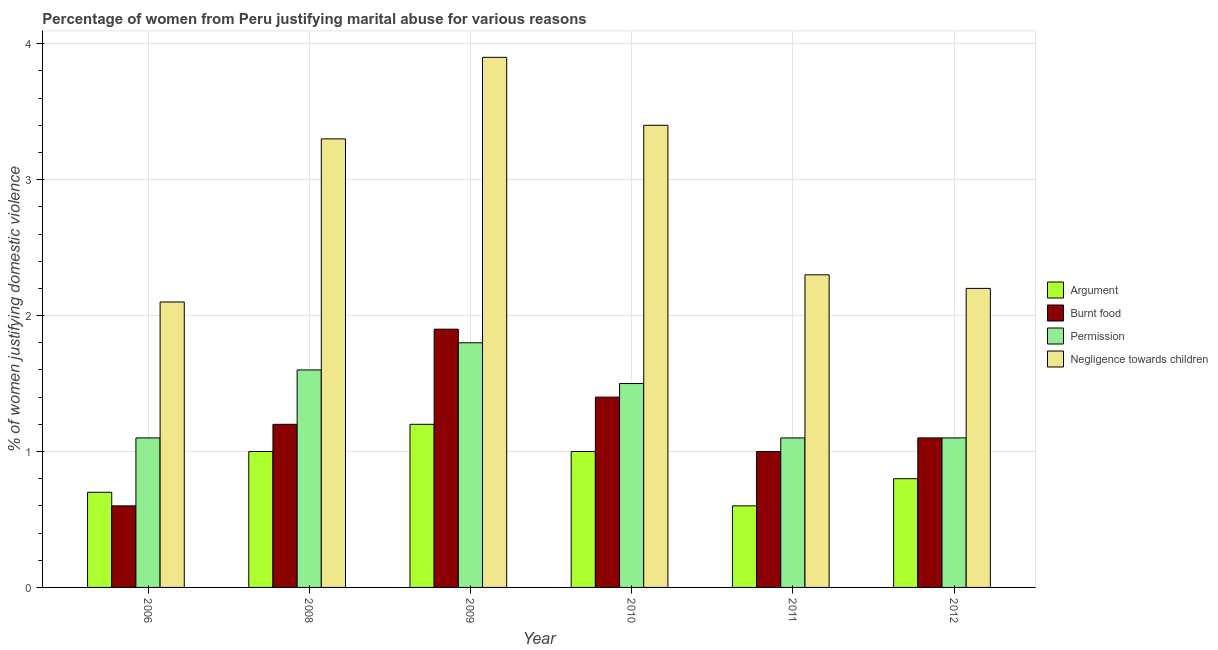How many groups of bars are there?
Your answer should be compact. 6. Are the number of bars on each tick of the X-axis equal?
Your response must be concise. Yes. How many bars are there on the 1st tick from the left?
Give a very brief answer. 4. What is the label of the 4th group of bars from the left?
Make the answer very short. 2010. Across all years, what is the maximum percentage of women justifying abuse in the case of an argument?
Give a very brief answer. 1.2. Across all years, what is the minimum percentage of women justifying abuse for burning food?
Ensure brevity in your answer.  0.6. What is the difference between the percentage of women justifying abuse for burning food in 2006 and that in 2009?
Provide a short and direct response. -1.3. What is the difference between the percentage of women justifying abuse for going without permission in 2008 and the percentage of women justifying abuse for burning food in 2006?
Ensure brevity in your answer.  0.5. What is the average percentage of women justifying abuse for showing negligence towards children per year?
Provide a short and direct response. 2.87. In how many years, is the percentage of women justifying abuse for going without permission greater than 1.8 %?
Offer a very short reply. 0. What is the ratio of the percentage of women justifying abuse for going without permission in 2009 to that in 2010?
Keep it short and to the point. 1.2. Is the percentage of women justifying abuse in the case of an argument in 2006 less than that in 2009?
Your answer should be compact. Yes. Is the difference between the percentage of women justifying abuse for going without permission in 2006 and 2010 greater than the difference between the percentage of women justifying abuse for showing negligence towards children in 2006 and 2010?
Give a very brief answer. No. What is the difference between the highest and the second highest percentage of women justifying abuse in the case of an argument?
Provide a succinct answer. 0.2. What is the difference between the highest and the lowest percentage of women justifying abuse for burning food?
Provide a succinct answer. 1.3. In how many years, is the percentage of women justifying abuse in the case of an argument greater than the average percentage of women justifying abuse in the case of an argument taken over all years?
Ensure brevity in your answer.  3. What does the 3rd bar from the left in 2012 represents?
Offer a terse response. Permission. What does the 2nd bar from the right in 2010 represents?
Provide a succinct answer. Permission. Is it the case that in every year, the sum of the percentage of women justifying abuse in the case of an argument and percentage of women justifying abuse for burning food is greater than the percentage of women justifying abuse for going without permission?
Provide a short and direct response. Yes. How many years are there in the graph?
Make the answer very short. 6. What is the difference between two consecutive major ticks on the Y-axis?
Offer a very short reply. 1. Does the graph contain any zero values?
Your answer should be compact. No. How many legend labels are there?
Offer a terse response. 4. How are the legend labels stacked?
Make the answer very short. Vertical. What is the title of the graph?
Keep it short and to the point. Percentage of women from Peru justifying marital abuse for various reasons. What is the label or title of the Y-axis?
Offer a terse response. % of women justifying domestic violence. What is the % of women justifying domestic violence of Argument in 2006?
Ensure brevity in your answer.  0.7. What is the % of women justifying domestic violence in Argument in 2008?
Provide a succinct answer. 1. What is the % of women justifying domestic violence of Burnt food in 2008?
Offer a very short reply. 1.2. What is the % of women justifying domestic violence in Negligence towards children in 2008?
Keep it short and to the point. 3.3. What is the % of women justifying domestic violence in Burnt food in 2009?
Give a very brief answer. 1.9. What is the % of women justifying domestic violence in Burnt food in 2010?
Ensure brevity in your answer.  1.4. What is the % of women justifying domestic violence of Permission in 2010?
Provide a succinct answer. 1.5. What is the % of women justifying domestic violence of Burnt food in 2011?
Give a very brief answer. 1. What is the % of women justifying domestic violence in Permission in 2011?
Offer a terse response. 1.1. What is the % of women justifying domestic violence of Argument in 2012?
Offer a very short reply. 0.8. What is the % of women justifying domestic violence in Burnt food in 2012?
Provide a short and direct response. 1.1. Across all years, what is the maximum % of women justifying domestic violence in Permission?
Make the answer very short. 1.8. Across all years, what is the minimum % of women justifying domestic violence of Permission?
Your response must be concise. 1.1. What is the total % of women justifying domestic violence of Argument in the graph?
Provide a succinct answer. 5.3. What is the total % of women justifying domestic violence of Permission in the graph?
Provide a succinct answer. 8.2. What is the total % of women justifying domestic violence of Negligence towards children in the graph?
Provide a succinct answer. 17.2. What is the difference between the % of women justifying domestic violence of Argument in 2006 and that in 2009?
Offer a very short reply. -0.5. What is the difference between the % of women justifying domestic violence in Burnt food in 2006 and that in 2009?
Keep it short and to the point. -1.3. What is the difference between the % of women justifying domestic violence in Argument in 2006 and that in 2010?
Provide a succinct answer. -0.3. What is the difference between the % of women justifying domestic violence of Burnt food in 2006 and that in 2010?
Give a very brief answer. -0.8. What is the difference between the % of women justifying domestic violence in Negligence towards children in 2006 and that in 2010?
Your response must be concise. -1.3. What is the difference between the % of women justifying domestic violence of Burnt food in 2006 and that in 2011?
Give a very brief answer. -0.4. What is the difference between the % of women justifying domestic violence of Permission in 2006 and that in 2012?
Your answer should be compact. 0. What is the difference between the % of women justifying domestic violence of Negligence towards children in 2006 and that in 2012?
Offer a very short reply. -0.1. What is the difference between the % of women justifying domestic violence in Burnt food in 2008 and that in 2009?
Provide a short and direct response. -0.7. What is the difference between the % of women justifying domestic violence of Negligence towards children in 2008 and that in 2009?
Ensure brevity in your answer.  -0.6. What is the difference between the % of women justifying domestic violence in Burnt food in 2008 and that in 2010?
Your response must be concise. -0.2. What is the difference between the % of women justifying domestic violence of Permission in 2008 and that in 2010?
Your response must be concise. 0.1. What is the difference between the % of women justifying domestic violence of Burnt food in 2008 and that in 2011?
Keep it short and to the point. 0.2. What is the difference between the % of women justifying domestic violence in Negligence towards children in 2008 and that in 2011?
Your response must be concise. 1. What is the difference between the % of women justifying domestic violence in Burnt food in 2008 and that in 2012?
Your response must be concise. 0.1. What is the difference between the % of women justifying domestic violence in Permission in 2008 and that in 2012?
Your response must be concise. 0.5. What is the difference between the % of women justifying domestic violence in Negligence towards children in 2008 and that in 2012?
Offer a very short reply. 1.1. What is the difference between the % of women justifying domestic violence of Negligence towards children in 2009 and that in 2010?
Keep it short and to the point. 0.5. What is the difference between the % of women justifying domestic violence in Burnt food in 2009 and that in 2011?
Offer a terse response. 0.9. What is the difference between the % of women justifying domestic violence in Negligence towards children in 2009 and that in 2011?
Your answer should be very brief. 1.6. What is the difference between the % of women justifying domestic violence of Argument in 2009 and that in 2012?
Make the answer very short. 0.4. What is the difference between the % of women justifying domestic violence in Burnt food in 2009 and that in 2012?
Ensure brevity in your answer.  0.8. What is the difference between the % of women justifying domestic violence of Negligence towards children in 2010 and that in 2012?
Make the answer very short. 1.2. What is the difference between the % of women justifying domestic violence of Argument in 2011 and that in 2012?
Your answer should be very brief. -0.2. What is the difference between the % of women justifying domestic violence in Burnt food in 2011 and that in 2012?
Make the answer very short. -0.1. What is the difference between the % of women justifying domestic violence in Permission in 2011 and that in 2012?
Give a very brief answer. 0. What is the difference between the % of women justifying domestic violence in Burnt food in 2006 and the % of women justifying domestic violence in Negligence towards children in 2008?
Make the answer very short. -2.7. What is the difference between the % of women justifying domestic violence in Argument in 2006 and the % of women justifying domestic violence in Permission in 2009?
Provide a short and direct response. -1.1. What is the difference between the % of women justifying domestic violence of Argument in 2006 and the % of women justifying domestic violence of Negligence towards children in 2009?
Give a very brief answer. -3.2. What is the difference between the % of women justifying domestic violence in Burnt food in 2006 and the % of women justifying domestic violence in Negligence towards children in 2009?
Provide a short and direct response. -3.3. What is the difference between the % of women justifying domestic violence of Argument in 2006 and the % of women justifying domestic violence of Burnt food in 2010?
Give a very brief answer. -0.7. What is the difference between the % of women justifying domestic violence in Argument in 2006 and the % of women justifying domestic violence in Permission in 2010?
Offer a very short reply. -0.8. What is the difference between the % of women justifying domestic violence in Argument in 2006 and the % of women justifying domestic violence in Negligence towards children in 2010?
Offer a very short reply. -2.7. What is the difference between the % of women justifying domestic violence in Permission in 2006 and the % of women justifying domestic violence in Negligence towards children in 2010?
Make the answer very short. -2.3. What is the difference between the % of women justifying domestic violence of Argument in 2006 and the % of women justifying domestic violence of Permission in 2011?
Your answer should be very brief. -0.4. What is the difference between the % of women justifying domestic violence in Burnt food in 2006 and the % of women justifying domestic violence in Permission in 2011?
Keep it short and to the point. -0.5. What is the difference between the % of women justifying domestic violence in Burnt food in 2006 and the % of women justifying domestic violence in Permission in 2012?
Make the answer very short. -0.5. What is the difference between the % of women justifying domestic violence in Burnt food in 2006 and the % of women justifying domestic violence in Negligence towards children in 2012?
Keep it short and to the point. -1.6. What is the difference between the % of women justifying domestic violence in Permission in 2006 and the % of women justifying domestic violence in Negligence towards children in 2012?
Your response must be concise. -1.1. What is the difference between the % of women justifying domestic violence in Burnt food in 2008 and the % of women justifying domestic violence in Permission in 2009?
Keep it short and to the point. -0.6. What is the difference between the % of women justifying domestic violence in Argument in 2008 and the % of women justifying domestic violence in Negligence towards children in 2010?
Provide a succinct answer. -2.4. What is the difference between the % of women justifying domestic violence in Burnt food in 2008 and the % of women justifying domestic violence in Negligence towards children in 2010?
Offer a very short reply. -2.2. What is the difference between the % of women justifying domestic violence of Permission in 2008 and the % of women justifying domestic violence of Negligence towards children in 2010?
Provide a succinct answer. -1.8. What is the difference between the % of women justifying domestic violence in Argument in 2008 and the % of women justifying domestic violence in Negligence towards children in 2011?
Provide a short and direct response. -1.3. What is the difference between the % of women justifying domestic violence of Argument in 2008 and the % of women justifying domestic violence of Burnt food in 2012?
Offer a terse response. -0.1. What is the difference between the % of women justifying domestic violence of Argument in 2008 and the % of women justifying domestic violence of Permission in 2012?
Give a very brief answer. -0.1. What is the difference between the % of women justifying domestic violence in Burnt food in 2008 and the % of women justifying domestic violence in Negligence towards children in 2012?
Your answer should be compact. -1. What is the difference between the % of women justifying domestic violence in Argument in 2009 and the % of women justifying domestic violence in Burnt food in 2010?
Offer a very short reply. -0.2. What is the difference between the % of women justifying domestic violence of Burnt food in 2009 and the % of women justifying domestic violence of Permission in 2010?
Provide a succinct answer. 0.4. What is the difference between the % of women justifying domestic violence of Argument in 2009 and the % of women justifying domestic violence of Permission in 2011?
Make the answer very short. 0.1. What is the difference between the % of women justifying domestic violence of Burnt food in 2009 and the % of women justifying domestic violence of Permission in 2011?
Provide a short and direct response. 0.8. What is the difference between the % of women justifying domestic violence in Argument in 2009 and the % of women justifying domestic violence in Permission in 2012?
Your response must be concise. 0.1. What is the difference between the % of women justifying domestic violence of Burnt food in 2009 and the % of women justifying domestic violence of Negligence towards children in 2012?
Offer a terse response. -0.3. What is the difference between the % of women justifying domestic violence in Argument in 2010 and the % of women justifying domestic violence in Negligence towards children in 2011?
Offer a terse response. -1.3. What is the difference between the % of women justifying domestic violence in Argument in 2010 and the % of women justifying domestic violence in Negligence towards children in 2012?
Your response must be concise. -1.2. What is the difference between the % of women justifying domestic violence in Burnt food in 2010 and the % of women justifying domestic violence in Permission in 2012?
Offer a very short reply. 0.3. What is the difference between the % of women justifying domestic violence of Argument in 2011 and the % of women justifying domestic violence of Burnt food in 2012?
Give a very brief answer. -0.5. What is the difference between the % of women justifying domestic violence of Argument in 2011 and the % of women justifying domestic violence of Permission in 2012?
Give a very brief answer. -0.5. What is the difference between the % of women justifying domestic violence in Argument in 2011 and the % of women justifying domestic violence in Negligence towards children in 2012?
Your response must be concise. -1.6. What is the difference between the % of women justifying domestic violence of Permission in 2011 and the % of women justifying domestic violence of Negligence towards children in 2012?
Make the answer very short. -1.1. What is the average % of women justifying domestic violence in Argument per year?
Provide a succinct answer. 0.88. What is the average % of women justifying domestic violence of Burnt food per year?
Keep it short and to the point. 1.2. What is the average % of women justifying domestic violence of Permission per year?
Provide a succinct answer. 1.37. What is the average % of women justifying domestic violence of Negligence towards children per year?
Offer a very short reply. 2.87. In the year 2006, what is the difference between the % of women justifying domestic violence of Burnt food and % of women justifying domestic violence of Permission?
Your answer should be compact. -0.5. In the year 2006, what is the difference between the % of women justifying domestic violence of Burnt food and % of women justifying domestic violence of Negligence towards children?
Ensure brevity in your answer.  -1.5. In the year 2006, what is the difference between the % of women justifying domestic violence in Permission and % of women justifying domestic violence in Negligence towards children?
Provide a succinct answer. -1. In the year 2008, what is the difference between the % of women justifying domestic violence of Permission and % of women justifying domestic violence of Negligence towards children?
Make the answer very short. -1.7. In the year 2009, what is the difference between the % of women justifying domestic violence of Permission and % of women justifying domestic violence of Negligence towards children?
Your response must be concise. -2.1. In the year 2010, what is the difference between the % of women justifying domestic violence in Argument and % of women justifying domestic violence in Burnt food?
Ensure brevity in your answer.  -0.4. In the year 2010, what is the difference between the % of women justifying domestic violence in Argument and % of women justifying domestic violence in Permission?
Your answer should be very brief. -0.5. In the year 2010, what is the difference between the % of women justifying domestic violence in Burnt food and % of women justifying domestic violence in Negligence towards children?
Ensure brevity in your answer.  -2. In the year 2010, what is the difference between the % of women justifying domestic violence in Permission and % of women justifying domestic violence in Negligence towards children?
Your response must be concise. -1.9. In the year 2011, what is the difference between the % of women justifying domestic violence of Argument and % of women justifying domestic violence of Burnt food?
Your answer should be very brief. -0.4. In the year 2011, what is the difference between the % of women justifying domestic violence of Argument and % of women justifying domestic violence of Negligence towards children?
Provide a succinct answer. -1.7. In the year 2011, what is the difference between the % of women justifying domestic violence of Burnt food and % of women justifying domestic violence of Negligence towards children?
Give a very brief answer. -1.3. In the year 2012, what is the difference between the % of women justifying domestic violence in Argument and % of women justifying domestic violence in Permission?
Give a very brief answer. -0.3. In the year 2012, what is the difference between the % of women justifying domestic violence of Argument and % of women justifying domestic violence of Negligence towards children?
Offer a very short reply. -1.4. In the year 2012, what is the difference between the % of women justifying domestic violence in Burnt food and % of women justifying domestic violence in Negligence towards children?
Offer a terse response. -1.1. What is the ratio of the % of women justifying domestic violence in Burnt food in 2006 to that in 2008?
Your answer should be compact. 0.5. What is the ratio of the % of women justifying domestic violence in Permission in 2006 to that in 2008?
Provide a short and direct response. 0.69. What is the ratio of the % of women justifying domestic violence in Negligence towards children in 2006 to that in 2008?
Offer a terse response. 0.64. What is the ratio of the % of women justifying domestic violence of Argument in 2006 to that in 2009?
Provide a succinct answer. 0.58. What is the ratio of the % of women justifying domestic violence in Burnt food in 2006 to that in 2009?
Make the answer very short. 0.32. What is the ratio of the % of women justifying domestic violence of Permission in 2006 to that in 2009?
Keep it short and to the point. 0.61. What is the ratio of the % of women justifying domestic violence in Negligence towards children in 2006 to that in 2009?
Your answer should be very brief. 0.54. What is the ratio of the % of women justifying domestic violence in Argument in 2006 to that in 2010?
Your answer should be compact. 0.7. What is the ratio of the % of women justifying domestic violence in Burnt food in 2006 to that in 2010?
Offer a terse response. 0.43. What is the ratio of the % of women justifying domestic violence in Permission in 2006 to that in 2010?
Ensure brevity in your answer.  0.73. What is the ratio of the % of women justifying domestic violence of Negligence towards children in 2006 to that in 2010?
Your response must be concise. 0.62. What is the ratio of the % of women justifying domestic violence of Burnt food in 2006 to that in 2011?
Provide a succinct answer. 0.6. What is the ratio of the % of women justifying domestic violence in Permission in 2006 to that in 2011?
Offer a terse response. 1. What is the ratio of the % of women justifying domestic violence of Negligence towards children in 2006 to that in 2011?
Provide a short and direct response. 0.91. What is the ratio of the % of women justifying domestic violence in Burnt food in 2006 to that in 2012?
Make the answer very short. 0.55. What is the ratio of the % of women justifying domestic violence of Permission in 2006 to that in 2012?
Your answer should be very brief. 1. What is the ratio of the % of women justifying domestic violence in Negligence towards children in 2006 to that in 2012?
Make the answer very short. 0.95. What is the ratio of the % of women justifying domestic violence of Burnt food in 2008 to that in 2009?
Provide a succinct answer. 0.63. What is the ratio of the % of women justifying domestic violence in Negligence towards children in 2008 to that in 2009?
Keep it short and to the point. 0.85. What is the ratio of the % of women justifying domestic violence of Burnt food in 2008 to that in 2010?
Ensure brevity in your answer.  0.86. What is the ratio of the % of women justifying domestic violence of Permission in 2008 to that in 2010?
Provide a succinct answer. 1.07. What is the ratio of the % of women justifying domestic violence in Negligence towards children in 2008 to that in 2010?
Ensure brevity in your answer.  0.97. What is the ratio of the % of women justifying domestic violence of Argument in 2008 to that in 2011?
Give a very brief answer. 1.67. What is the ratio of the % of women justifying domestic violence in Permission in 2008 to that in 2011?
Give a very brief answer. 1.45. What is the ratio of the % of women justifying domestic violence of Negligence towards children in 2008 to that in 2011?
Offer a very short reply. 1.43. What is the ratio of the % of women justifying domestic violence of Argument in 2008 to that in 2012?
Keep it short and to the point. 1.25. What is the ratio of the % of women justifying domestic violence in Permission in 2008 to that in 2012?
Give a very brief answer. 1.45. What is the ratio of the % of women justifying domestic violence in Negligence towards children in 2008 to that in 2012?
Your answer should be compact. 1.5. What is the ratio of the % of women justifying domestic violence in Argument in 2009 to that in 2010?
Keep it short and to the point. 1.2. What is the ratio of the % of women justifying domestic violence in Burnt food in 2009 to that in 2010?
Give a very brief answer. 1.36. What is the ratio of the % of women justifying domestic violence of Negligence towards children in 2009 to that in 2010?
Give a very brief answer. 1.15. What is the ratio of the % of women justifying domestic violence of Argument in 2009 to that in 2011?
Make the answer very short. 2. What is the ratio of the % of women justifying domestic violence in Permission in 2009 to that in 2011?
Offer a terse response. 1.64. What is the ratio of the % of women justifying domestic violence in Negligence towards children in 2009 to that in 2011?
Make the answer very short. 1.7. What is the ratio of the % of women justifying domestic violence of Burnt food in 2009 to that in 2012?
Give a very brief answer. 1.73. What is the ratio of the % of women justifying domestic violence in Permission in 2009 to that in 2012?
Your answer should be compact. 1.64. What is the ratio of the % of women justifying domestic violence in Negligence towards children in 2009 to that in 2012?
Keep it short and to the point. 1.77. What is the ratio of the % of women justifying domestic violence in Argument in 2010 to that in 2011?
Make the answer very short. 1.67. What is the ratio of the % of women justifying domestic violence in Burnt food in 2010 to that in 2011?
Provide a succinct answer. 1.4. What is the ratio of the % of women justifying domestic violence of Permission in 2010 to that in 2011?
Your answer should be compact. 1.36. What is the ratio of the % of women justifying domestic violence of Negligence towards children in 2010 to that in 2011?
Ensure brevity in your answer.  1.48. What is the ratio of the % of women justifying domestic violence of Burnt food in 2010 to that in 2012?
Ensure brevity in your answer.  1.27. What is the ratio of the % of women justifying domestic violence of Permission in 2010 to that in 2012?
Your answer should be very brief. 1.36. What is the ratio of the % of women justifying domestic violence of Negligence towards children in 2010 to that in 2012?
Offer a very short reply. 1.55. What is the ratio of the % of women justifying domestic violence of Argument in 2011 to that in 2012?
Your answer should be very brief. 0.75. What is the ratio of the % of women justifying domestic violence of Burnt food in 2011 to that in 2012?
Provide a short and direct response. 0.91. What is the ratio of the % of women justifying domestic violence in Negligence towards children in 2011 to that in 2012?
Your answer should be very brief. 1.05. What is the difference between the highest and the second highest % of women justifying domestic violence in Argument?
Give a very brief answer. 0.2. What is the difference between the highest and the second highest % of women justifying domestic violence in Burnt food?
Your response must be concise. 0.5. What is the difference between the highest and the second highest % of women justifying domestic violence of Permission?
Give a very brief answer. 0.2. What is the difference between the highest and the lowest % of women justifying domestic violence of Argument?
Your answer should be compact. 0.6. What is the difference between the highest and the lowest % of women justifying domestic violence in Burnt food?
Give a very brief answer. 1.3. What is the difference between the highest and the lowest % of women justifying domestic violence in Permission?
Provide a succinct answer. 0.7. 